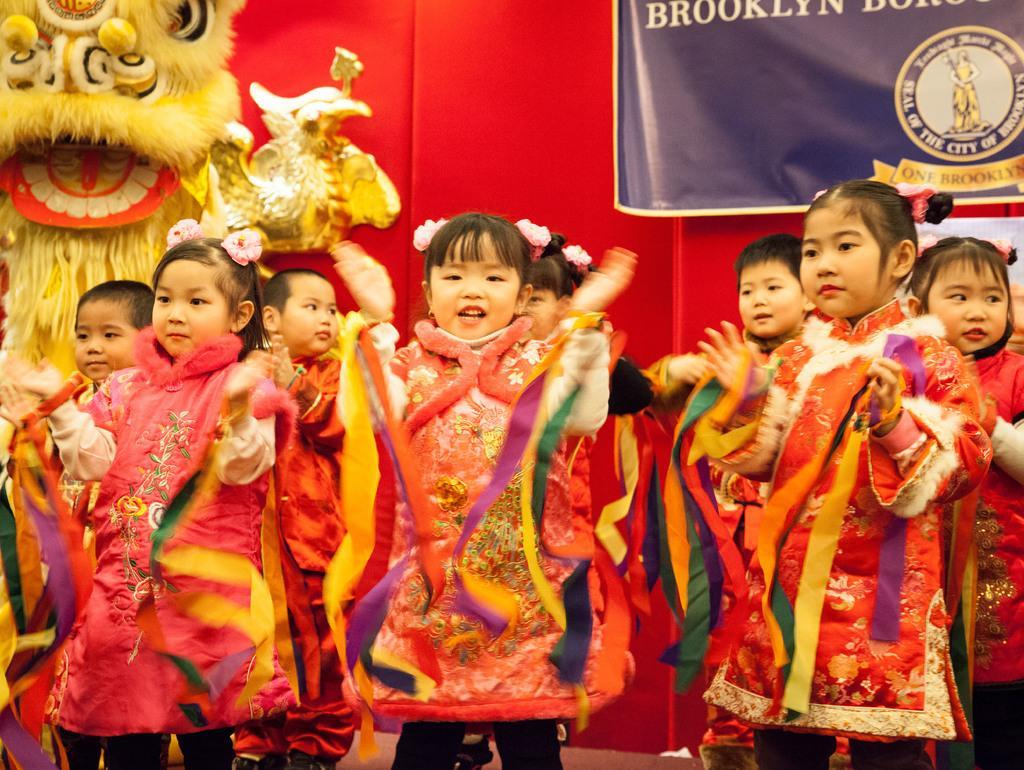Can you describe this image briefly? In this image there are persons standing. And at the back there is a wall. On the wall there is a banner with logo and text written in it. And at the side there is an object and a decorative dress. 